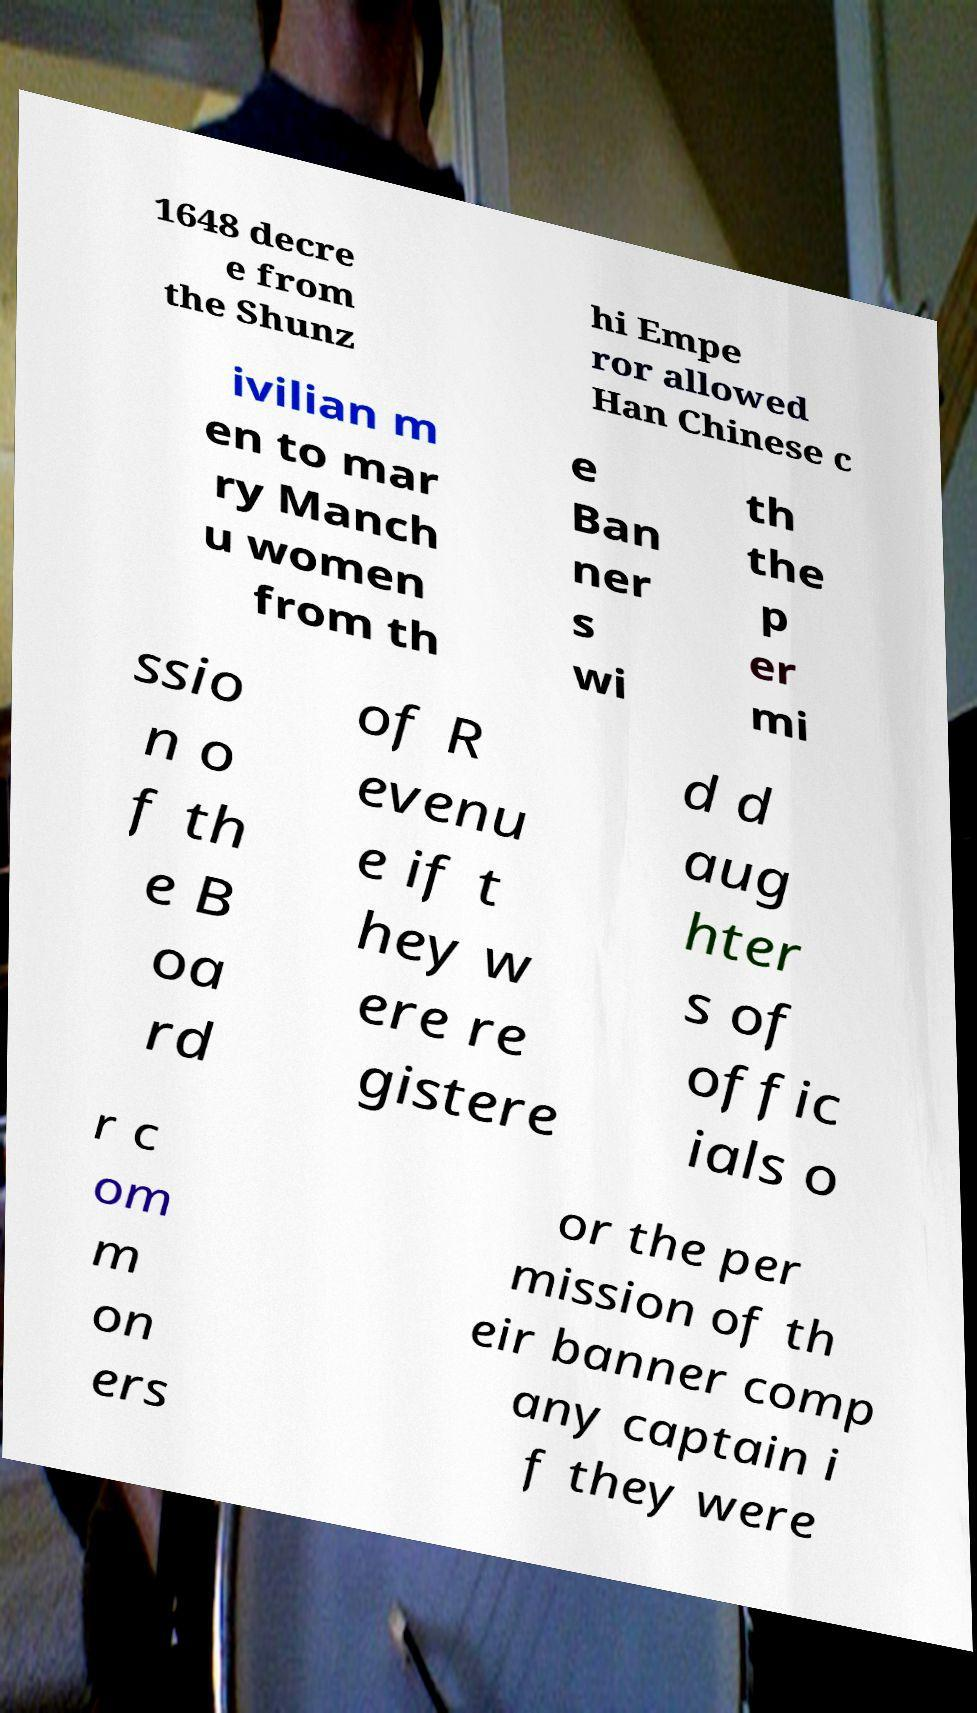Could you assist in decoding the text presented in this image and type it out clearly? 1648 decre e from the Shunz hi Empe ror allowed Han Chinese c ivilian m en to mar ry Manch u women from th e Ban ner s wi th the p er mi ssio n o f th e B oa rd of R evenu e if t hey w ere re gistere d d aug hter s of offic ials o r c om m on ers or the per mission of th eir banner comp any captain i f they were 